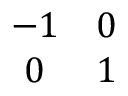Convert formula to latex. <formula><loc_0><loc_0><loc_500><loc_500>\begin{array} { c c } { - 1 } & { 0 } \\ { 0 } & { 1 } \end{array}</formula> 